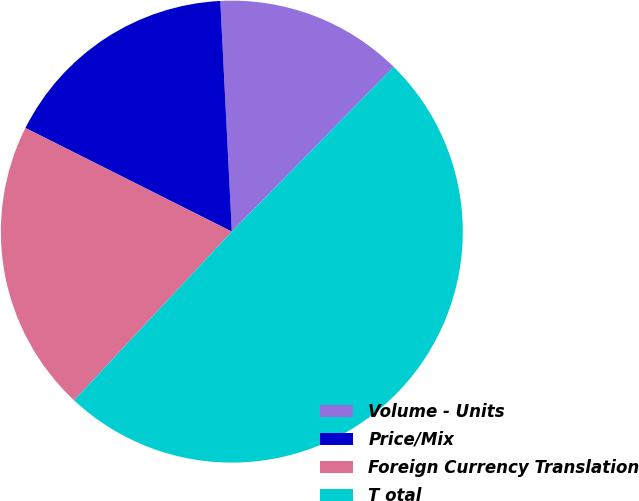Convert chart to OTSL. <chart><loc_0><loc_0><loc_500><loc_500><pie_chart><fcel>Volume - Units<fcel>Price/Mix<fcel>Foreign Currency Translation<fcel>T otal<nl><fcel>13.15%<fcel>16.8%<fcel>20.44%<fcel>49.61%<nl></chart> 